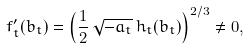Convert formula to latex. <formula><loc_0><loc_0><loc_500><loc_500>f _ { t } ^ { \prime } ( b _ { t } ) = \left ( \frac { 1 } { 2 } \, \sqrt { - a _ { t } } \, h _ { t } ( b _ { t } ) \right ) ^ { 2 / 3 } \neq 0 ,</formula> 